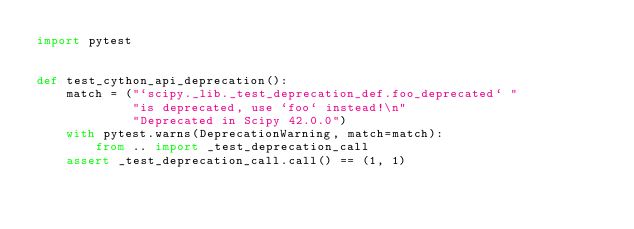<code> <loc_0><loc_0><loc_500><loc_500><_Python_>import pytest


def test_cython_api_deprecation():
    match = ("`scipy._lib._test_deprecation_def.foo_deprecated` "
             "is deprecated, use `foo` instead!\n"
             "Deprecated in Scipy 42.0.0")
    with pytest.warns(DeprecationWarning, match=match):
        from .. import _test_deprecation_call
    assert _test_deprecation_call.call() == (1, 1)
</code> 